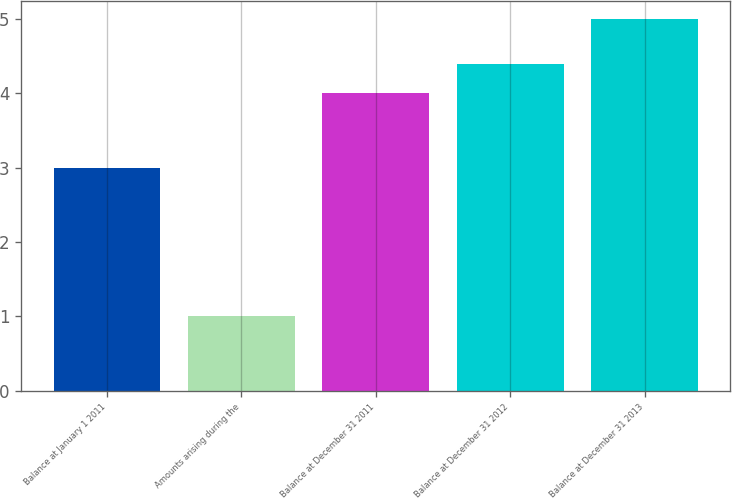<chart> <loc_0><loc_0><loc_500><loc_500><bar_chart><fcel>Balance at January 1 2011<fcel>Amounts arising during the<fcel>Balance at December 31 2011<fcel>Balance at December 31 2012<fcel>Balance at December 31 2013<nl><fcel>3<fcel>1<fcel>4<fcel>4.4<fcel>5<nl></chart> 